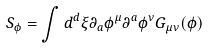<formula> <loc_0><loc_0><loc_500><loc_500>S _ { \phi } = \int d ^ { d } \xi \partial _ { a } \phi ^ { \mu } \partial ^ { a } \phi ^ { \nu } G _ { \mu \nu } ( \phi )</formula> 